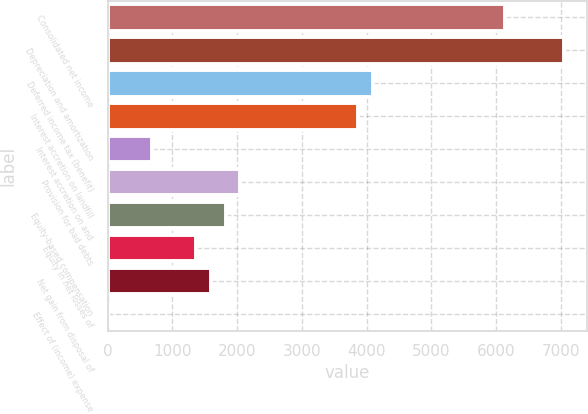<chart> <loc_0><loc_0><loc_500><loc_500><bar_chart><fcel>Consolidated net income<fcel>Depreciation and amortization<fcel>Deferred income tax (benefit)<fcel>Interest accretion on landfill<fcel>Interest accretion on and<fcel>Provision for bad debts<fcel>Equity-based compensation<fcel>Equity in net losses of<fcel>Net gain from disposal of<fcel>Effect of (income) expense<nl><fcel>6140.8<fcel>7050.4<fcel>4094.2<fcel>3866.8<fcel>683.2<fcel>2047.6<fcel>1820.2<fcel>1365.4<fcel>1592.8<fcel>1<nl></chart> 